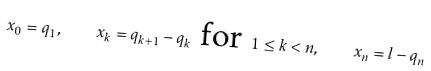<formula> <loc_0><loc_0><loc_500><loc_500>x _ { 0 } = q _ { 1 } , \quad x _ { k } = q _ { k + 1 } - q _ { k } \text { for } 1 \leq k < n , \quad x _ { n } = l - q _ { n }</formula> 